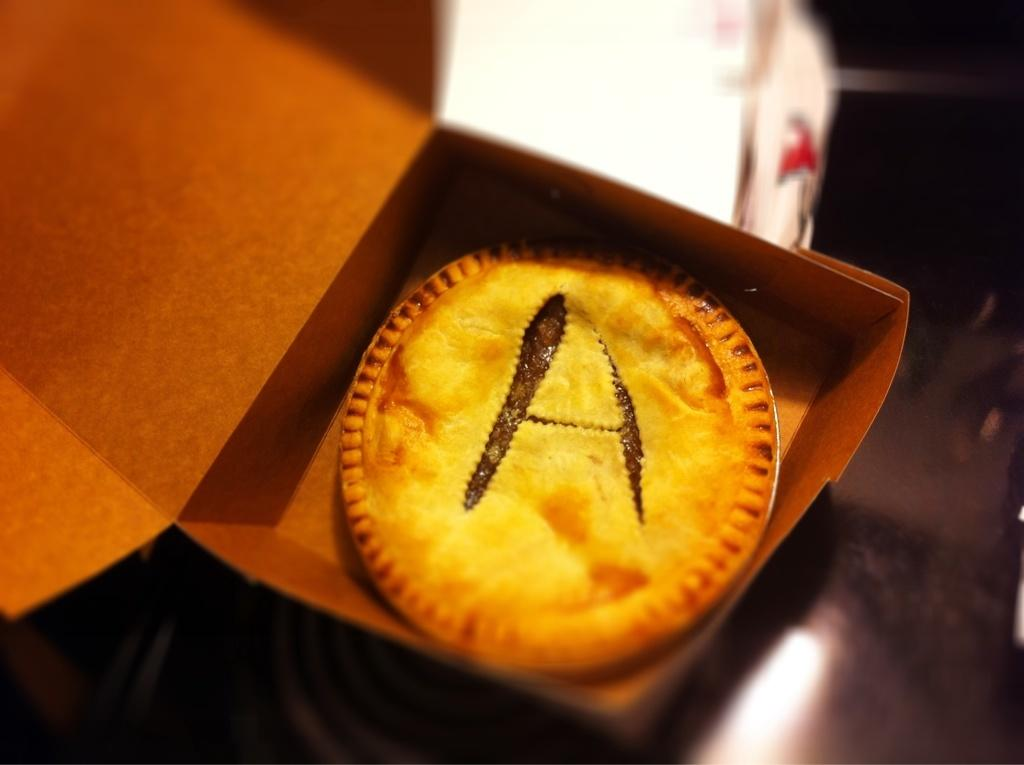What type of food item is in the box in the image? The specific type of food item in the box cannot be determined from the provided facts. What can be said about the background of the image? The background of the image is blurred. What color is the polish on the turkey's nails during recess in the image? There is no turkey, polish, or recess present in the image. 